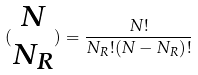<formula> <loc_0><loc_0><loc_500><loc_500>( \begin{matrix} N \\ N _ { R } \end{matrix} ) = \frac { N ! } { N _ { R } ! ( N - N _ { R } ) ! }</formula> 